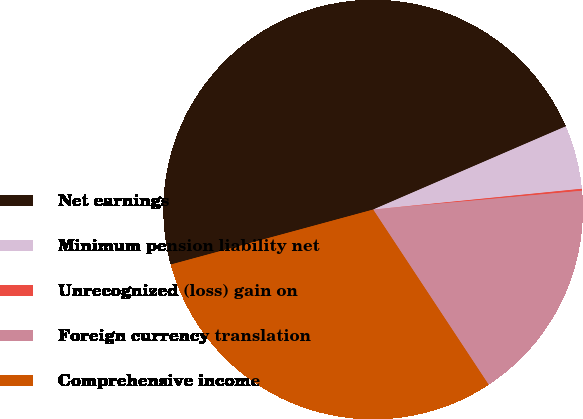Convert chart to OTSL. <chart><loc_0><loc_0><loc_500><loc_500><pie_chart><fcel>Net earnings<fcel>Minimum pension liability net<fcel>Unrecognized (loss) gain on<fcel>Foreign currency translation<fcel>Comprehensive income<nl><fcel>47.73%<fcel>4.91%<fcel>0.15%<fcel>17.15%<fcel>30.06%<nl></chart> 